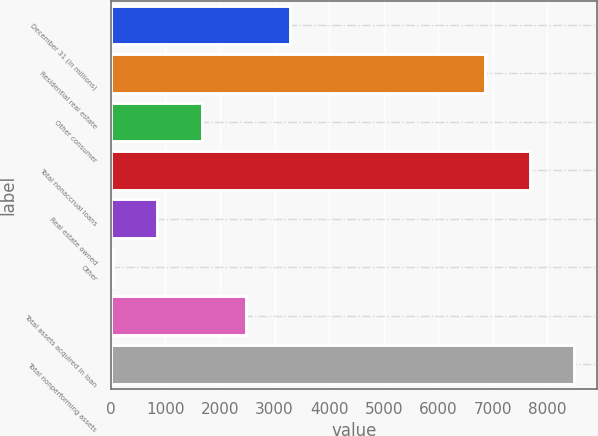Convert chart. <chart><loc_0><loc_0><loc_500><loc_500><bar_chart><fcel>December 31 (in millions)<fcel>Residential real estate<fcel>Other consumer<fcel>Total nonaccrual loans<fcel>Real estate owned<fcel>Other<fcel>Total assets acquired in loan<fcel>Total nonperforming assets<nl><fcel>3285<fcel>6864<fcel>1663<fcel>7675<fcel>852<fcel>41<fcel>2474<fcel>8486<nl></chart> 